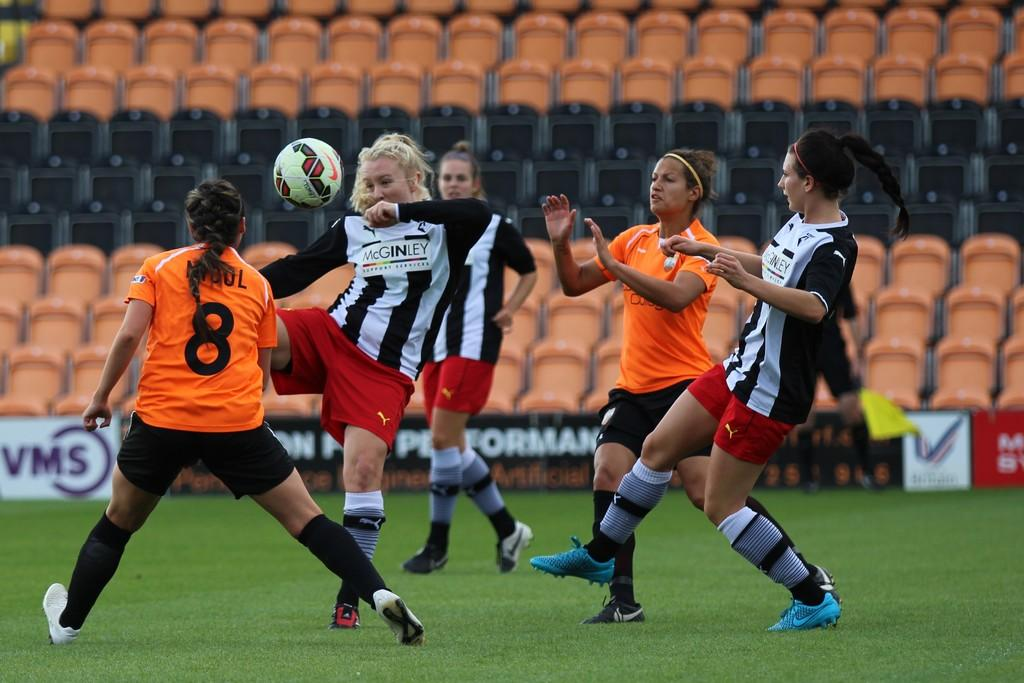What activity are the ladies engaged in? The ladies are playing football. What can be seen in the background of the image? There are banners and chairs in the background. Where is the scene taking place? The scene is on a grass lawn. What type of clothing are the ladies wearing on their feet? The ladies are wearing shoes and socks. What is the main object used in the game? There is a football present. What statement can be seen written on the pocket of one of the ladies? There is no statement written on the pocket of any of the ladies, as they are not wearing clothing with pockets. 